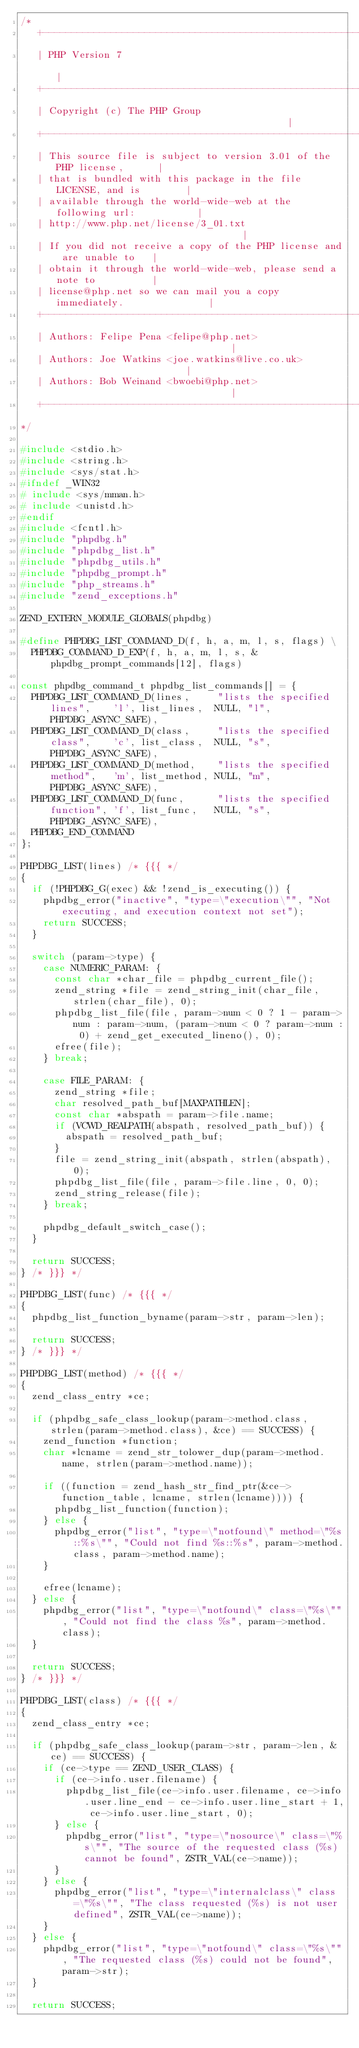<code> <loc_0><loc_0><loc_500><loc_500><_C_>/*
   +----------------------------------------------------------------------+
   | PHP Version 7                                                        |
   +----------------------------------------------------------------------+
   | Copyright (c) The PHP Group                                          |
   +----------------------------------------------------------------------+
   | This source file is subject to version 3.01 of the PHP license,      |
   | that is bundled with this package in the file LICENSE, and is        |
   | available through the world-wide-web at the following url:           |
   | http://www.php.net/license/3_01.txt                                  |
   | If you did not receive a copy of the PHP license and are unable to   |
   | obtain it through the world-wide-web, please send a note to          |
   | license@php.net so we can mail you a copy immediately.               |
   +----------------------------------------------------------------------+
   | Authors: Felipe Pena <felipe@php.net>                                |
   | Authors: Joe Watkins <joe.watkins@live.co.uk>                        |
   | Authors: Bob Weinand <bwoebi@php.net>                                |
   +----------------------------------------------------------------------+
*/

#include <stdio.h>
#include <string.h>
#include <sys/stat.h>
#ifndef _WIN32
#	include <sys/mman.h>
#	include <unistd.h>
#endif
#include <fcntl.h>
#include "phpdbg.h"
#include "phpdbg_list.h"
#include "phpdbg_utils.h"
#include "phpdbg_prompt.h"
#include "php_streams.h"
#include "zend_exceptions.h"

ZEND_EXTERN_MODULE_GLOBALS(phpdbg)

#define PHPDBG_LIST_COMMAND_D(f, h, a, m, l, s, flags) \
	PHPDBG_COMMAND_D_EXP(f, h, a, m, l, s, &phpdbg_prompt_commands[12], flags)

const phpdbg_command_t phpdbg_list_commands[] = {
	PHPDBG_LIST_COMMAND_D(lines,     "lists the specified lines",    'l', list_lines,  NULL, "l", PHPDBG_ASYNC_SAFE),
	PHPDBG_LIST_COMMAND_D(class,     "lists the specified class",    'c', list_class,  NULL, "s", PHPDBG_ASYNC_SAFE),
	PHPDBG_LIST_COMMAND_D(method,    "lists the specified method",   'm', list_method, NULL, "m", PHPDBG_ASYNC_SAFE),
	PHPDBG_LIST_COMMAND_D(func,      "lists the specified function", 'f', list_func,   NULL, "s", PHPDBG_ASYNC_SAFE),
	PHPDBG_END_COMMAND
};

PHPDBG_LIST(lines) /* {{{ */
{
	if (!PHPDBG_G(exec) && !zend_is_executing()) {
		phpdbg_error("inactive", "type=\"execution\"", "Not executing, and execution context not set");
		return SUCCESS;
	}

	switch (param->type) {
		case NUMERIC_PARAM: {
			const char *char_file = phpdbg_current_file();
			zend_string *file = zend_string_init(char_file, strlen(char_file), 0);
			phpdbg_list_file(file, param->num < 0 ? 1 - param->num : param->num, (param->num < 0 ? param->num : 0) + zend_get_executed_lineno(), 0);
			efree(file);
		} break;

		case FILE_PARAM: {
			zend_string *file;
			char resolved_path_buf[MAXPATHLEN];
			const char *abspath = param->file.name;
			if (VCWD_REALPATH(abspath, resolved_path_buf)) {
				abspath = resolved_path_buf;
			}
			file = zend_string_init(abspath, strlen(abspath), 0);
			phpdbg_list_file(file, param->file.line, 0, 0);
			zend_string_release(file);
		} break;

		phpdbg_default_switch_case();
	}

	return SUCCESS;
} /* }}} */

PHPDBG_LIST(func) /* {{{ */
{
	phpdbg_list_function_byname(param->str, param->len);

	return SUCCESS;
} /* }}} */

PHPDBG_LIST(method) /* {{{ */
{
	zend_class_entry *ce;

	if (phpdbg_safe_class_lookup(param->method.class, strlen(param->method.class), &ce) == SUCCESS) {
		zend_function *function;
		char *lcname = zend_str_tolower_dup(param->method.name, strlen(param->method.name));

		if ((function = zend_hash_str_find_ptr(&ce->function_table, lcname, strlen(lcname)))) {
			phpdbg_list_function(function);
		} else {
			phpdbg_error("list", "type=\"notfound\" method=\"%s::%s\"", "Could not find %s::%s", param->method.class, param->method.name);
		}

		efree(lcname);
	} else {
		phpdbg_error("list", "type=\"notfound\" class=\"%s\"", "Could not find the class %s", param->method.class);
	}

	return SUCCESS;
} /* }}} */

PHPDBG_LIST(class) /* {{{ */
{
	zend_class_entry *ce;

	if (phpdbg_safe_class_lookup(param->str, param->len, &ce) == SUCCESS) {
		if (ce->type == ZEND_USER_CLASS) {
			if (ce->info.user.filename) {
				phpdbg_list_file(ce->info.user.filename, ce->info.user.line_end - ce->info.user.line_start + 1, ce->info.user.line_start, 0);
			} else {
				phpdbg_error("list", "type=\"nosource\" class=\"%s\"", "The source of the requested class (%s) cannot be found", ZSTR_VAL(ce->name));
			}
		} else {
			phpdbg_error("list", "type=\"internalclass\" class=\"%s\"", "The class requested (%s) is not user defined", ZSTR_VAL(ce->name));
		}
	} else {
		phpdbg_error("list", "type=\"notfound\" class=\"%s\"", "The requested class (%s) could not be found", param->str);
	}

	return SUCCESS;</code> 